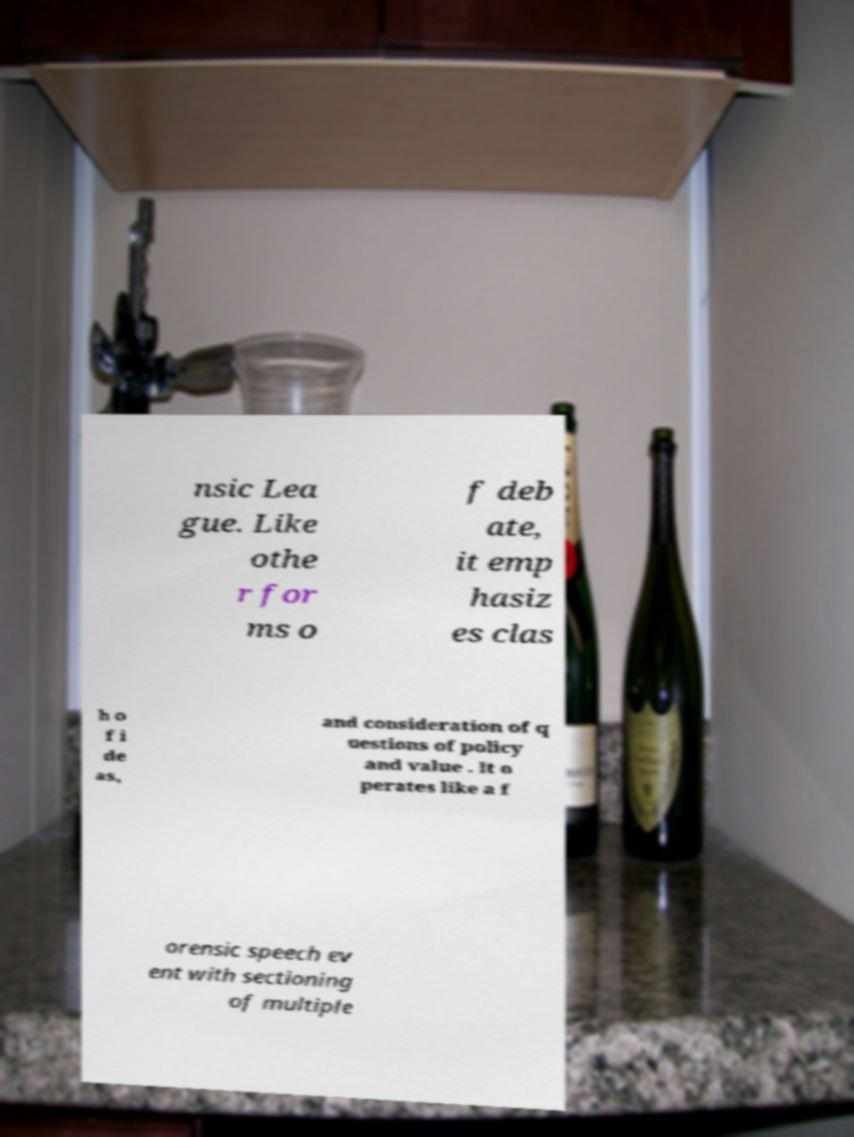I need the written content from this picture converted into text. Can you do that? nsic Lea gue. Like othe r for ms o f deb ate, it emp hasiz es clas h o f i de as, and consideration of q uestions of policy and value . It o perates like a f orensic speech ev ent with sectioning of multiple 